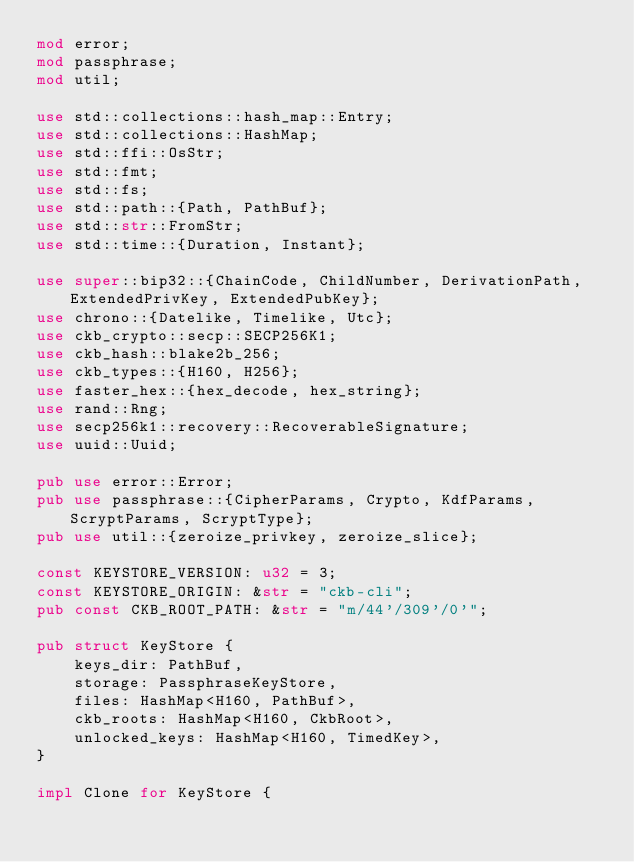<code> <loc_0><loc_0><loc_500><loc_500><_Rust_>mod error;
mod passphrase;
mod util;

use std::collections::hash_map::Entry;
use std::collections::HashMap;
use std::ffi::OsStr;
use std::fmt;
use std::fs;
use std::path::{Path, PathBuf};
use std::str::FromStr;
use std::time::{Duration, Instant};

use super::bip32::{ChainCode, ChildNumber, DerivationPath, ExtendedPrivKey, ExtendedPubKey};
use chrono::{Datelike, Timelike, Utc};
use ckb_crypto::secp::SECP256K1;
use ckb_hash::blake2b_256;
use ckb_types::{H160, H256};
use faster_hex::{hex_decode, hex_string};
use rand::Rng;
use secp256k1::recovery::RecoverableSignature;
use uuid::Uuid;

pub use error::Error;
pub use passphrase::{CipherParams, Crypto, KdfParams, ScryptParams, ScryptType};
pub use util::{zeroize_privkey, zeroize_slice};

const KEYSTORE_VERSION: u32 = 3;
const KEYSTORE_ORIGIN: &str = "ckb-cli";
pub const CKB_ROOT_PATH: &str = "m/44'/309'/0'";

pub struct KeyStore {
    keys_dir: PathBuf,
    storage: PassphraseKeyStore,
    files: HashMap<H160, PathBuf>,
    ckb_roots: HashMap<H160, CkbRoot>,
    unlocked_keys: HashMap<H160, TimedKey>,
}

impl Clone for KeyStore {</code> 